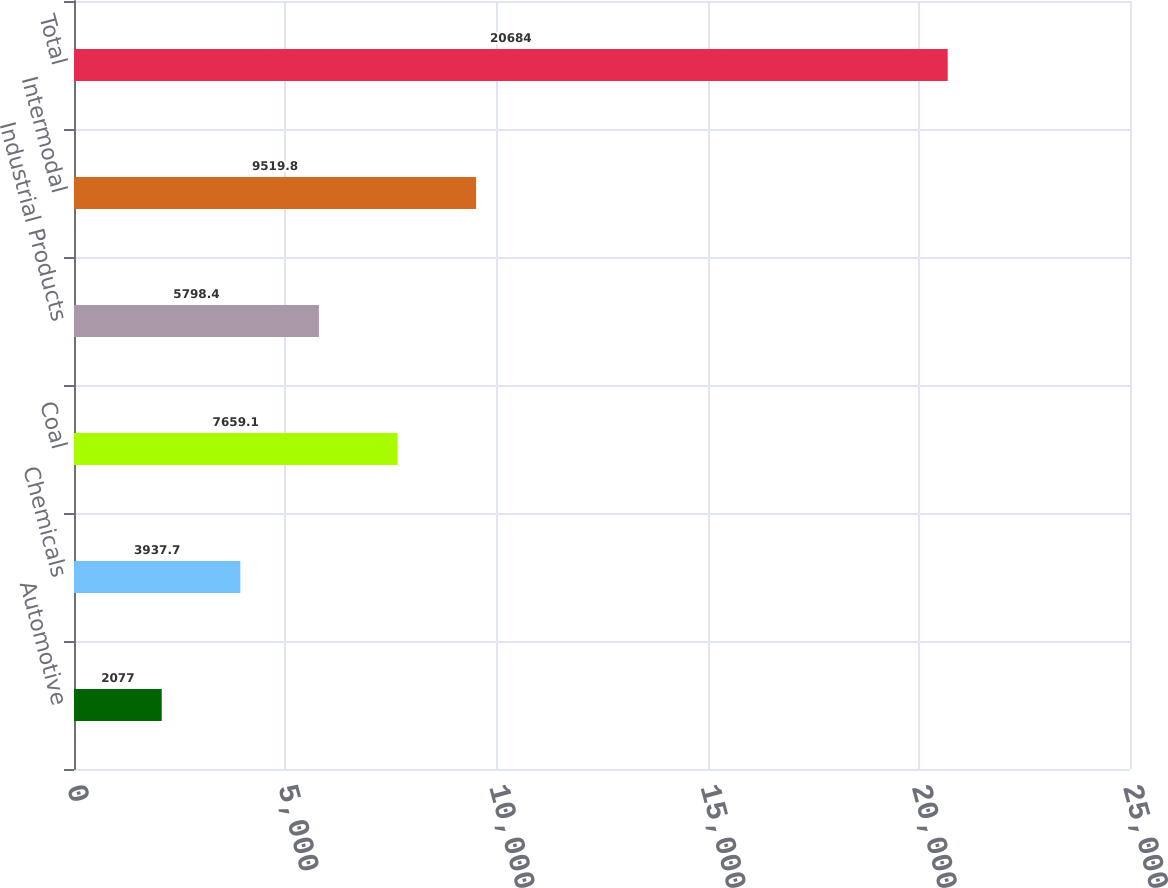Convert chart to OTSL. <chart><loc_0><loc_0><loc_500><loc_500><bar_chart><fcel>Automotive<fcel>Chemicals<fcel>Coal<fcel>Industrial Products<fcel>Intermodal<fcel>Total<nl><fcel>2077<fcel>3937.7<fcel>7659.1<fcel>5798.4<fcel>9519.8<fcel>20684<nl></chart> 